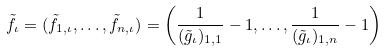<formula> <loc_0><loc_0><loc_500><loc_500>\tilde { f } _ { \iota } = ( \tilde { f } _ { 1 , \iota } , \dots , \tilde { f } _ { n , \iota } ) = \left ( \frac { 1 } { ( \tilde { g } _ { \iota } ) _ { 1 , 1 } } - 1 , \dots , \frac { 1 } { ( \tilde { g } _ { \iota } ) _ { 1 , n } } - 1 \right )</formula> 